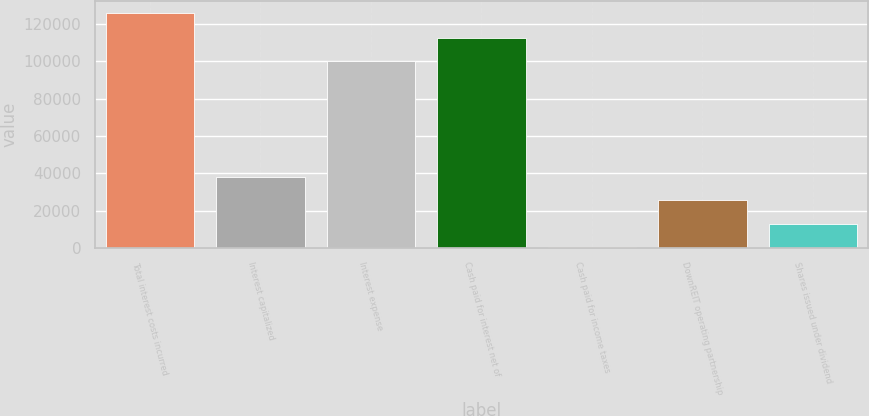<chart> <loc_0><loc_0><loc_500><loc_500><bar_chart><fcel>Total interest costs incurred<fcel>Interest capitalized<fcel>Interest expense<fcel>Cash paid for interest net of<fcel>Cash paid for income taxes<fcel>DownREIT operating partnership<fcel>Shares issued under dividend<nl><fcel>125684<fcel>37951.6<fcel>100125<fcel>112658<fcel>352<fcel>25418.4<fcel>12885.2<nl></chart> 